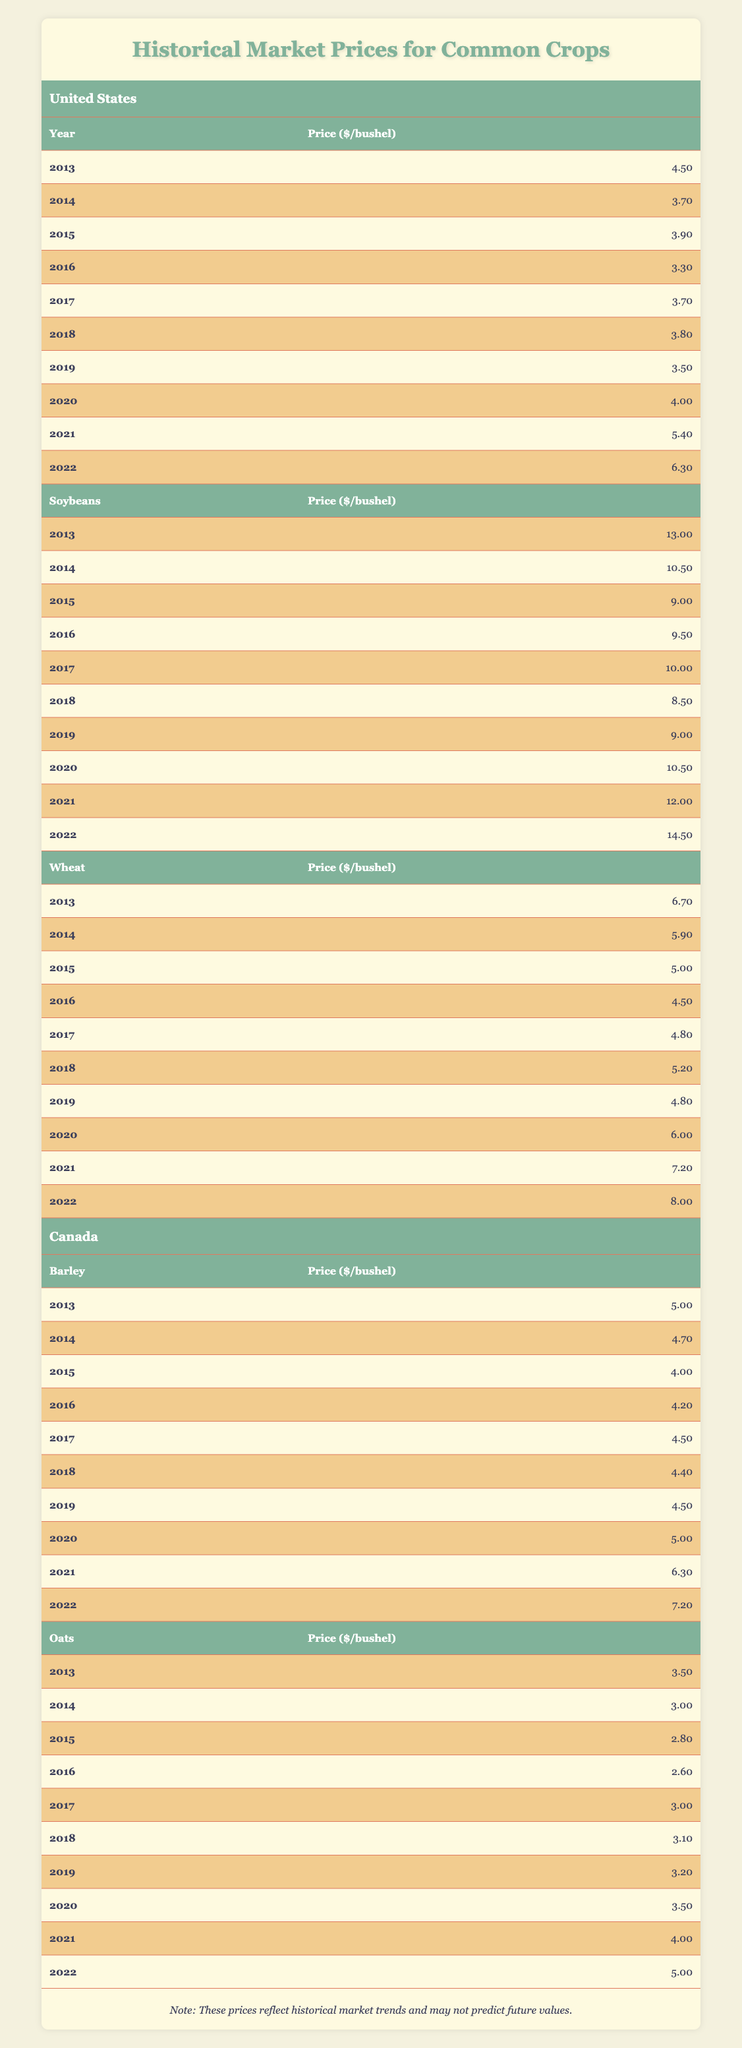What was the price of corn in 2021? The price of corn for the year 2021 is listed directly in the table under the "United States" section, where it shows 5.40.
Answer: 5.40 What year had the highest price for soybeans? By looking through the soybean prices from years 2013 to 2022, the highest price occurs in 2022 at 14.50.
Answer: 2022 How much did wheat cost in 2016 compared to 2015? The price of wheat in 2016 is 4.50 and in 2015 it is 5.00. The difference can be calculated as 5.00 - 4.50 = 0.50.
Answer: 0.50 Did the price of oats increase every year from 2013 to 2022? By reviewing the prices of oats, they initially decreased from 2013 to 2016, then increased from 2017 to 2022. Therefore, the statement is false.
Answer: No What was the average price of barley from 2020 to 2022? The prices of barley for those years are 5.00 (2020), 6.30 (2021), and 7.20 (2022). To find the average, add them: 5.00 + 6.30 + 7.20 = 18.50, then divide by 3 to get 18.50 / 3 = 6.17.
Answer: 6.17 Which crop had the largest price drop from 2014 to 2015? Checking the prices, corn dropped from 3.70 in 2014 to 3.90 in 2015 (an increase), soybeans dropped from 10.50 to 9.00, a drop of 1.50, and wheat dropped from 5.90 to 5.00, a drop of 0.90. The largest drop is in soybeans with a decline of 1.50.
Answer: Soybeans Which country had a higher price for wheat in 2022 compared to 2021? The price of wheat in the United States in 2021 is 7.20 and in 2022 is 8.00. The corresponding 2022 price is also 8.00 for wheat in the United States, which is higher than Canada’s wheat prices. Therefore, the answer is the United States.
Answer: United States What is the total price of corn over the past decade? To find the total price of corn from 2013 to 2022, you add all the yearly prices: 4.50 + 3.70 + 3.90 + 3.30 + 3.70 + 3.80 + 3.50 + 4.00 + 5.40 + 6.30 = 40.10.
Answer: 40.10 How did the price of soybeans change from 2013 to 2022? The price of soybeans started at 13.00 in 2013 and increased to 14.50 in 2022. This means it increased overall, specifically by 1.50 over the 10 years.
Answer: Increased by 1.50 